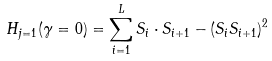<formula> <loc_0><loc_0><loc_500><loc_500>H _ { j = 1 } ( \gamma = 0 ) = \sum _ { i = 1 } ^ { L } S _ { i } \cdot S _ { i + 1 } - ( S _ { i } S _ { i + 1 } ) ^ { 2 }</formula> 